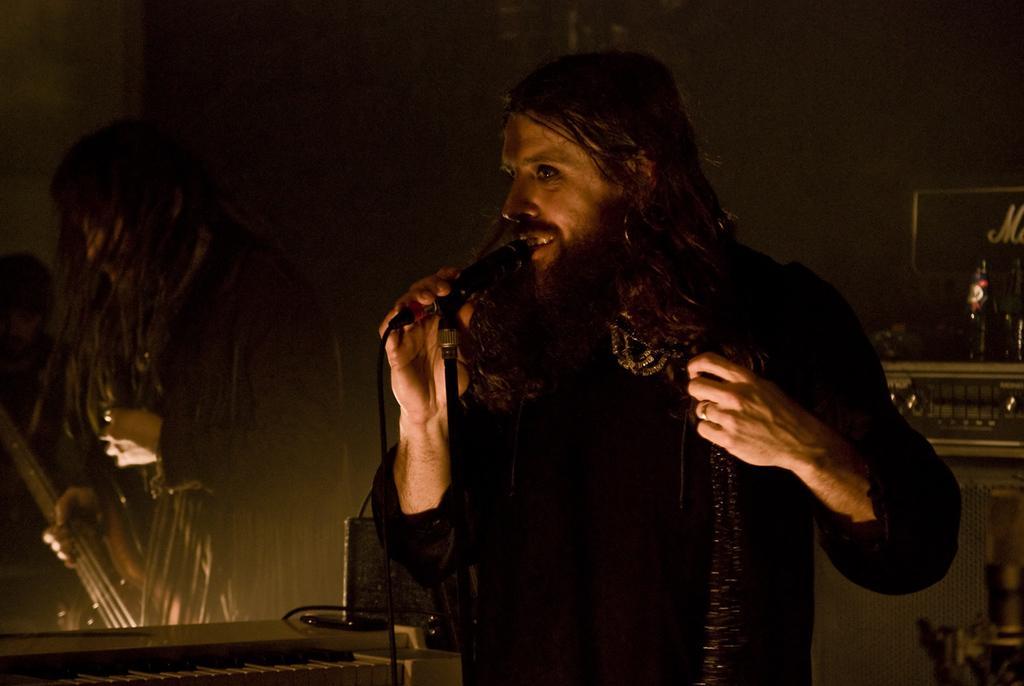Could you give a brief overview of what you see in this image? In this picture there is a man who is holding a mic and singing. 